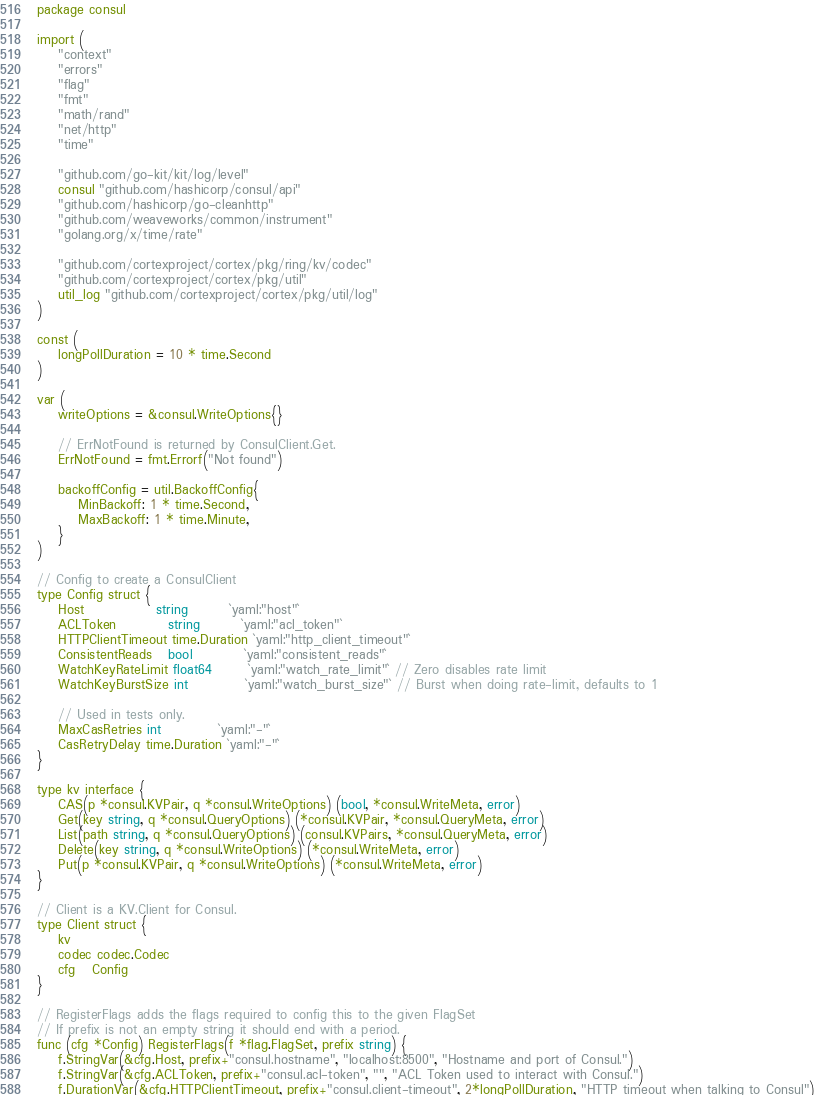Convert code to text. <code><loc_0><loc_0><loc_500><loc_500><_Go_>package consul

import (
	"context"
	"errors"
	"flag"
	"fmt"
	"math/rand"
	"net/http"
	"time"

	"github.com/go-kit/kit/log/level"
	consul "github.com/hashicorp/consul/api"
	"github.com/hashicorp/go-cleanhttp"
	"github.com/weaveworks/common/instrument"
	"golang.org/x/time/rate"

	"github.com/cortexproject/cortex/pkg/ring/kv/codec"
	"github.com/cortexproject/cortex/pkg/util"
	util_log "github.com/cortexproject/cortex/pkg/util/log"
)

const (
	longPollDuration = 10 * time.Second
)

var (
	writeOptions = &consul.WriteOptions{}

	// ErrNotFound is returned by ConsulClient.Get.
	ErrNotFound = fmt.Errorf("Not found")

	backoffConfig = util.BackoffConfig{
		MinBackoff: 1 * time.Second,
		MaxBackoff: 1 * time.Minute,
	}
)

// Config to create a ConsulClient
type Config struct {
	Host              string        `yaml:"host"`
	ACLToken          string        `yaml:"acl_token"`
	HTTPClientTimeout time.Duration `yaml:"http_client_timeout"`
	ConsistentReads   bool          `yaml:"consistent_reads"`
	WatchKeyRateLimit float64       `yaml:"watch_rate_limit"` // Zero disables rate limit
	WatchKeyBurstSize int           `yaml:"watch_burst_size"` // Burst when doing rate-limit, defaults to 1

	// Used in tests only.
	MaxCasRetries int           `yaml:"-"`
	CasRetryDelay time.Duration `yaml:"-"`
}

type kv interface {
	CAS(p *consul.KVPair, q *consul.WriteOptions) (bool, *consul.WriteMeta, error)
	Get(key string, q *consul.QueryOptions) (*consul.KVPair, *consul.QueryMeta, error)
	List(path string, q *consul.QueryOptions) (consul.KVPairs, *consul.QueryMeta, error)
	Delete(key string, q *consul.WriteOptions) (*consul.WriteMeta, error)
	Put(p *consul.KVPair, q *consul.WriteOptions) (*consul.WriteMeta, error)
}

// Client is a KV.Client for Consul.
type Client struct {
	kv
	codec codec.Codec
	cfg   Config
}

// RegisterFlags adds the flags required to config this to the given FlagSet
// If prefix is not an empty string it should end with a period.
func (cfg *Config) RegisterFlags(f *flag.FlagSet, prefix string) {
	f.StringVar(&cfg.Host, prefix+"consul.hostname", "localhost:8500", "Hostname and port of Consul.")
	f.StringVar(&cfg.ACLToken, prefix+"consul.acl-token", "", "ACL Token used to interact with Consul.")
	f.DurationVar(&cfg.HTTPClientTimeout, prefix+"consul.client-timeout", 2*longPollDuration, "HTTP timeout when talking to Consul")</code> 